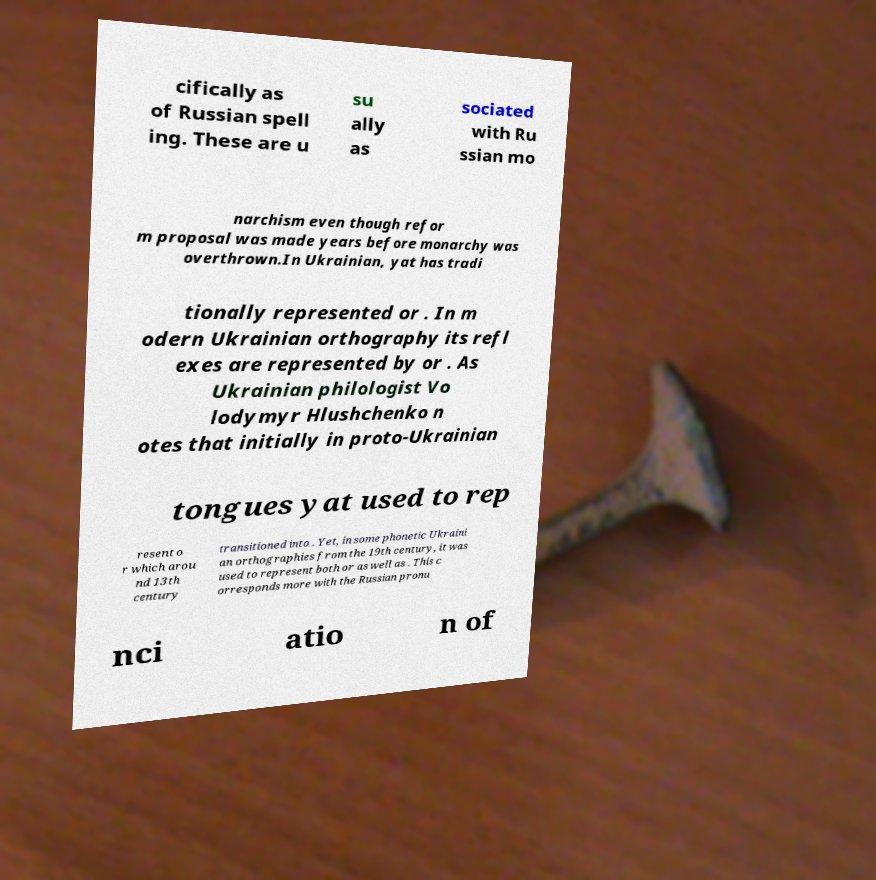For documentation purposes, I need the text within this image transcribed. Could you provide that? cifically as of Russian spell ing. These are u su ally as sociated with Ru ssian mo narchism even though refor m proposal was made years before monarchy was overthrown.In Ukrainian, yat has tradi tionally represented or . In m odern Ukrainian orthography its refl exes are represented by or . As Ukrainian philologist Vo lodymyr Hlushchenko n otes that initially in proto-Ukrainian tongues yat used to rep resent o r which arou nd 13th century transitioned into . Yet, in some phonetic Ukraini an orthographies from the 19th century, it was used to represent both or as well as . This c orresponds more with the Russian pronu nci atio n of 